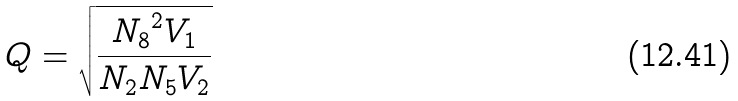<formula> <loc_0><loc_0><loc_500><loc_500>Q = \sqrt { \frac { { N _ { 8 } } ^ { 2 } V _ { 1 } } { N _ { 2 } N _ { 5 } V _ { 2 } } }</formula> 